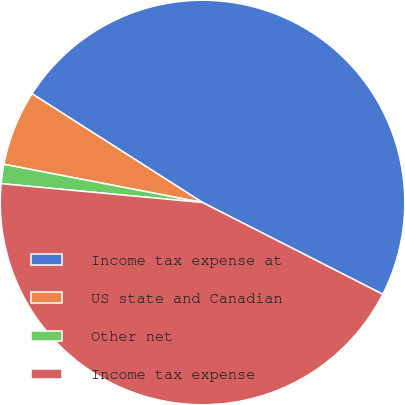<chart> <loc_0><loc_0><loc_500><loc_500><pie_chart><fcel>Income tax expense at<fcel>US state and Canadian<fcel>Other net<fcel>Income tax expense<nl><fcel>48.46%<fcel>6.01%<fcel>1.54%<fcel>43.99%<nl></chart> 